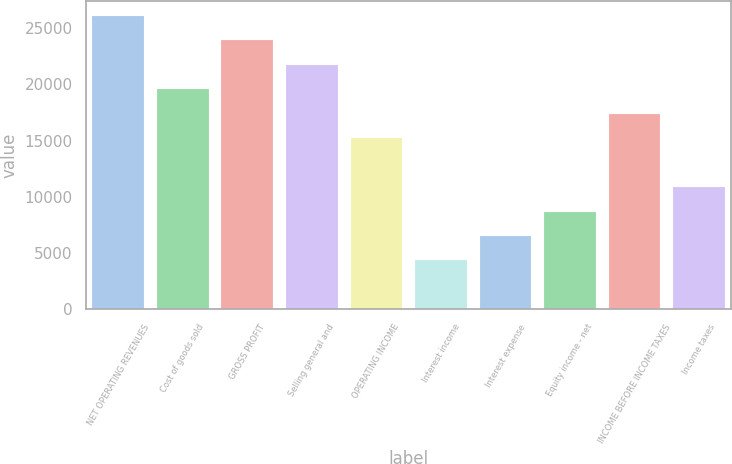<chart> <loc_0><loc_0><loc_500><loc_500><bar_chart><fcel>NET OPERATING REVENUES<fcel>Cost of goods sold<fcel>GROSS PROFIT<fcel>Selling general and<fcel>OPERATING INCOME<fcel>Interest income<fcel>Interest expense<fcel>Equity income - net<fcel>INCOME BEFORE INCOME TAXES<fcel>Income taxes<nl><fcel>26090<fcel>19568<fcel>23916<fcel>21742<fcel>15220<fcel>4350<fcel>6524<fcel>8698<fcel>17394<fcel>10872<nl></chart> 